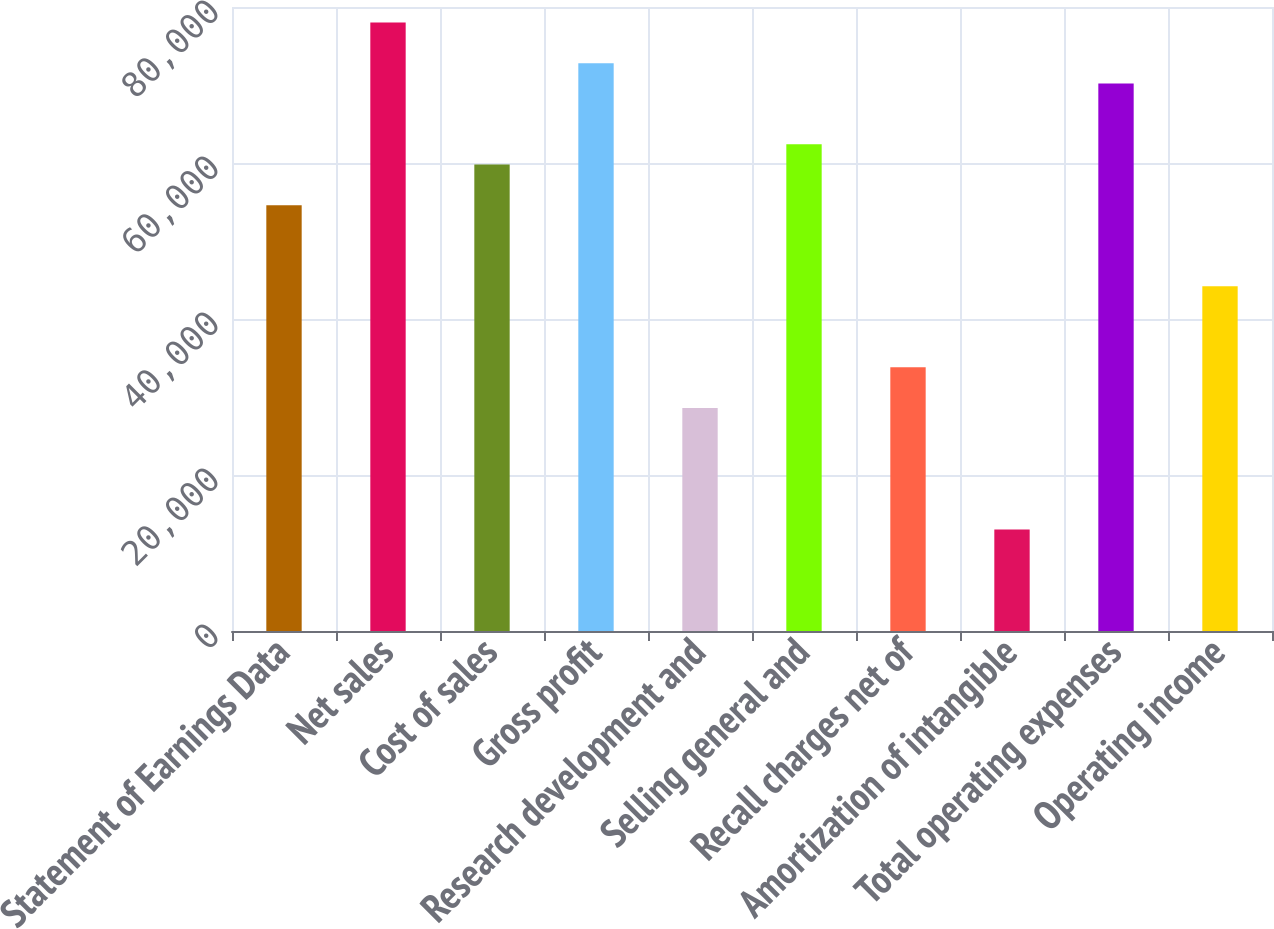Convert chart. <chart><loc_0><loc_0><loc_500><loc_500><bar_chart><fcel>Statement of Earnings Data<fcel>Net sales<fcel>Cost of sales<fcel>Gross profit<fcel>Research development and<fcel>Selling general and<fcel>Recall charges net of<fcel>Amortization of intangible<fcel>Total operating expenses<fcel>Operating income<nl><fcel>54598.5<fcel>77997.4<fcel>59798.3<fcel>72797.6<fcel>28599.8<fcel>62398.1<fcel>33799.6<fcel>13000.6<fcel>70197.8<fcel>44199.1<nl></chart> 